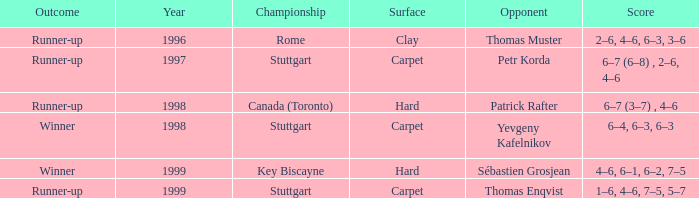What title event following 1997 recorded the score 1–6, 4–6, 7–5, 5–7? Stuttgart. I'm looking to parse the entire table for insights. Could you assist me with that? {'header': ['Outcome', 'Year', 'Championship', 'Surface', 'Opponent', 'Score'], 'rows': [['Runner-up', '1996', 'Rome', 'Clay', 'Thomas Muster', '2–6, 4–6, 6–3, 3–6'], ['Runner-up', '1997', 'Stuttgart', 'Carpet', 'Petr Korda', '6–7 (6–8) , 2–6, 4–6'], ['Runner-up', '1998', 'Canada (Toronto)', 'Hard', 'Patrick Rafter', '6–7 (3–7) , 4–6'], ['Winner', '1998', 'Stuttgart', 'Carpet', 'Yevgeny Kafelnikov', '6–4, 6–3, 6–3'], ['Winner', '1999', 'Key Biscayne', 'Hard', 'Sébastien Grosjean', '4–6, 6–1, 6–2, 7–5'], ['Runner-up', '1999', 'Stuttgart', 'Carpet', 'Thomas Enqvist', '1–6, 4–6, 7–5, 5–7']]} 